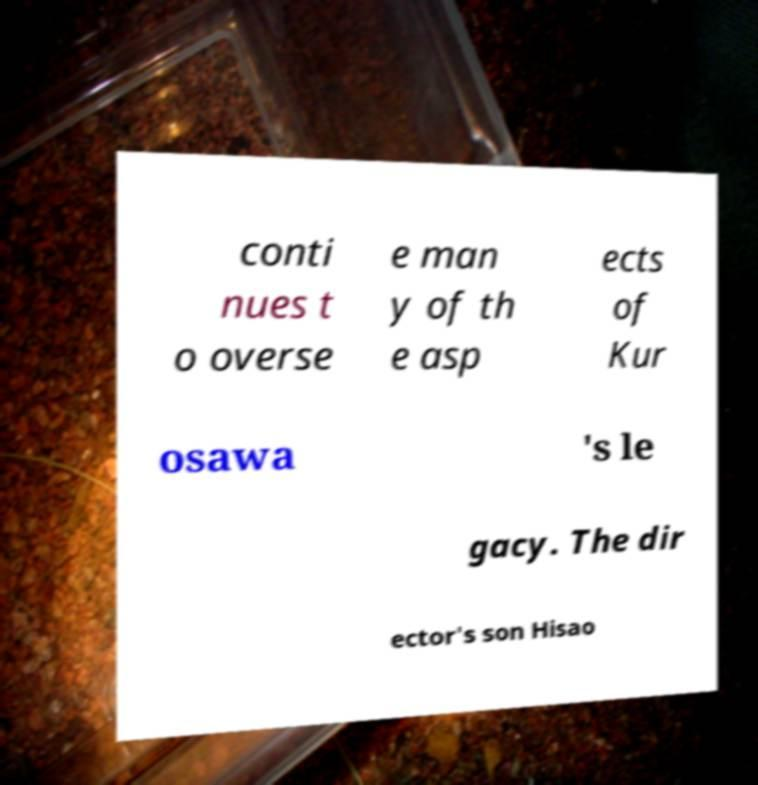For documentation purposes, I need the text within this image transcribed. Could you provide that? conti nues t o overse e man y of th e asp ects of Kur osawa 's le gacy. The dir ector's son Hisao 